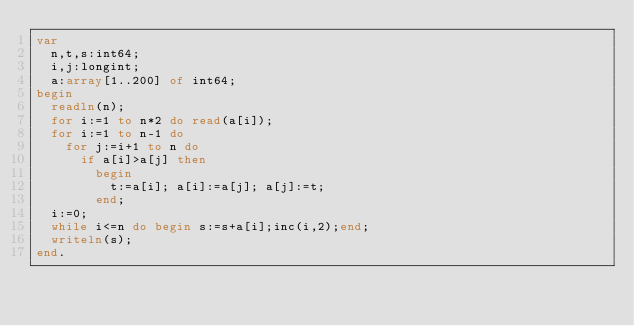<code> <loc_0><loc_0><loc_500><loc_500><_Pascal_>var
  n,t,s:int64;
  i,j:longint;
  a:array[1..200] of int64;
begin
  readln(n);
  for i:=1 to n*2 do read(a[i]);
  for i:=1 to n-1 do
    for j:=i+1 to n do
      if a[i]>a[j] then
        begin
          t:=a[i]; a[i]:=a[j]; a[j]:=t;
        end;
  i:=0;
  while i<=n do begin s:=s+a[i];inc(i,2);end;
  writeln(s);
end.</code> 